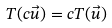<formula> <loc_0><loc_0><loc_500><loc_500>T ( c \vec { u } ) = c T ( \vec { u } )</formula> 